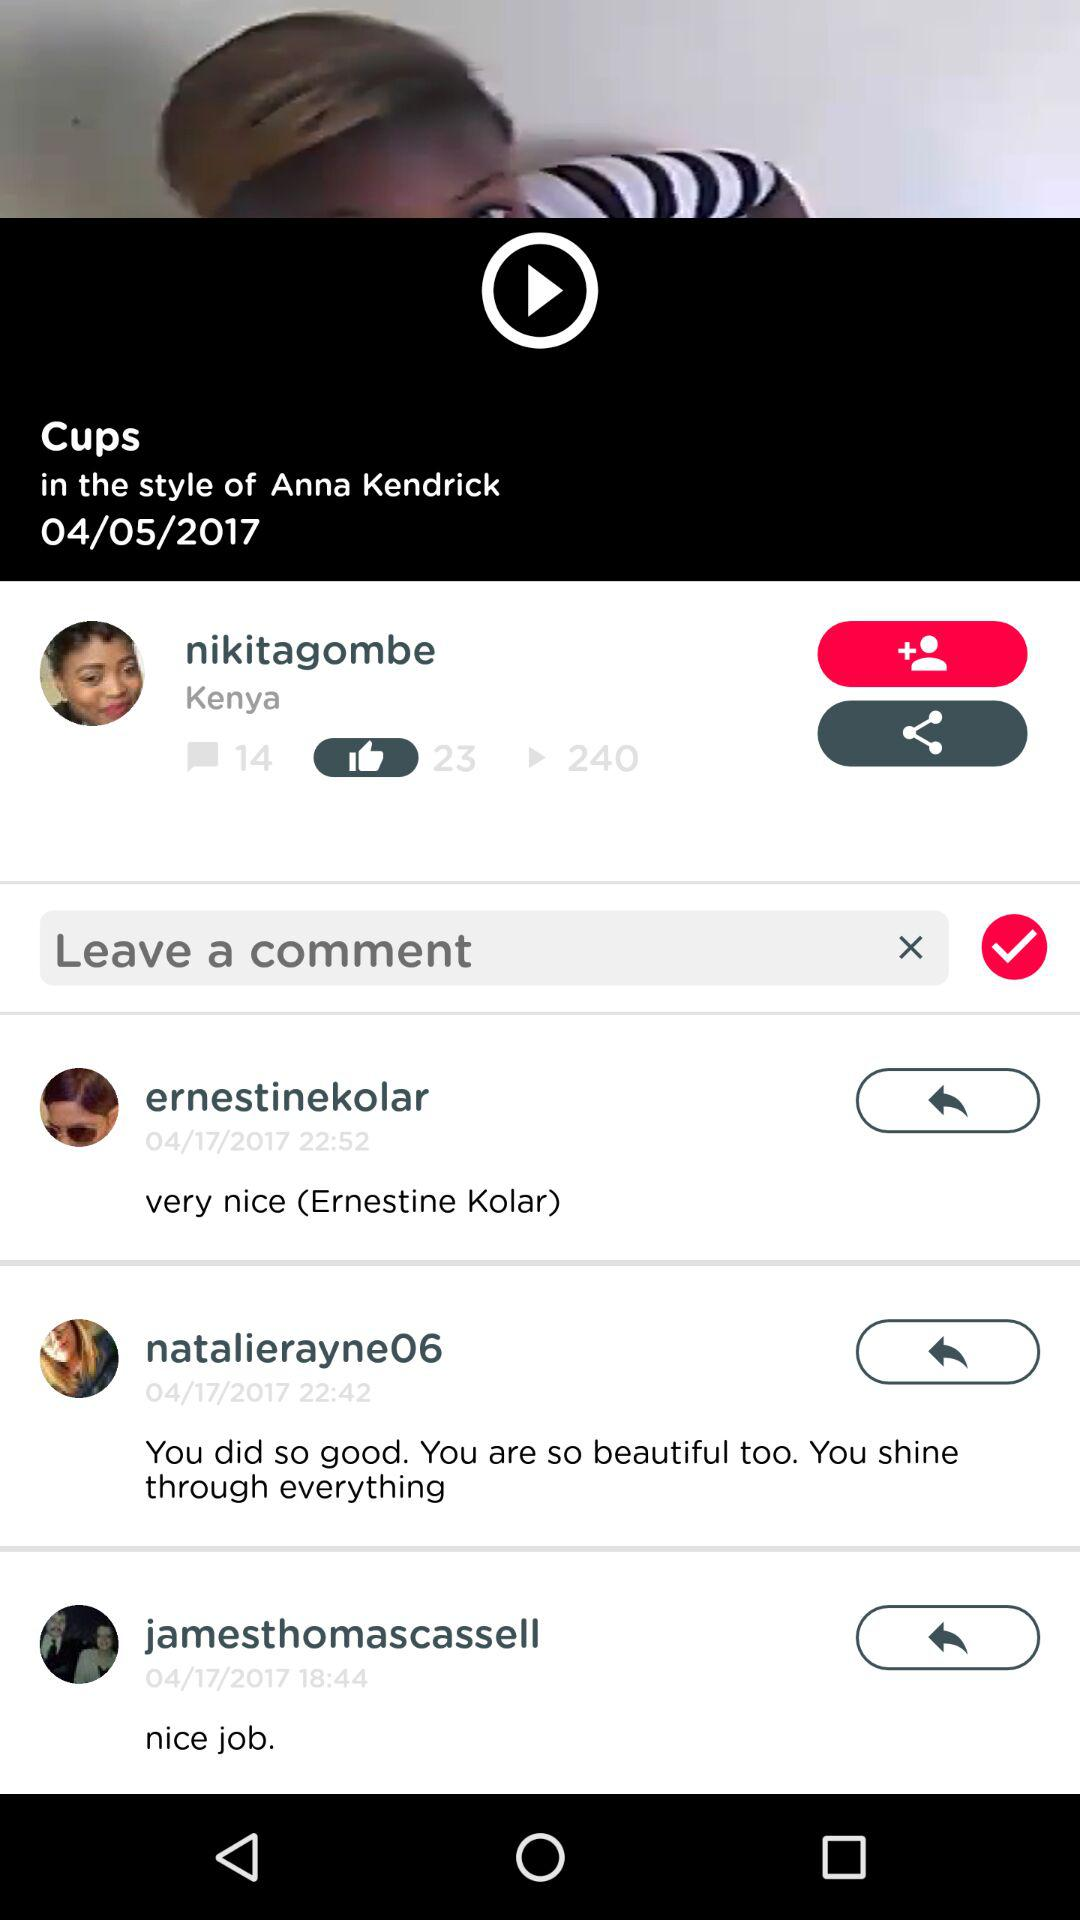What comment did "jamesthomascassell" post on the video? The comment "jamesthomascassell" posted on the video was "nice job.". 